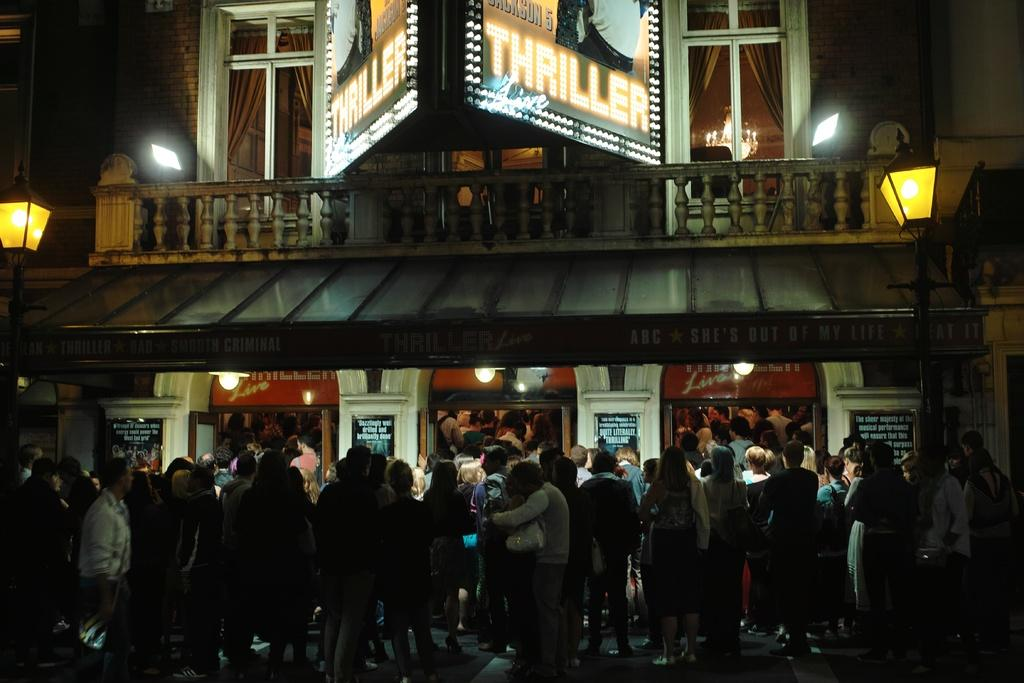<image>
Create a compact narrative representing the image presented. The large crowd was there to see "Thriller" live. 